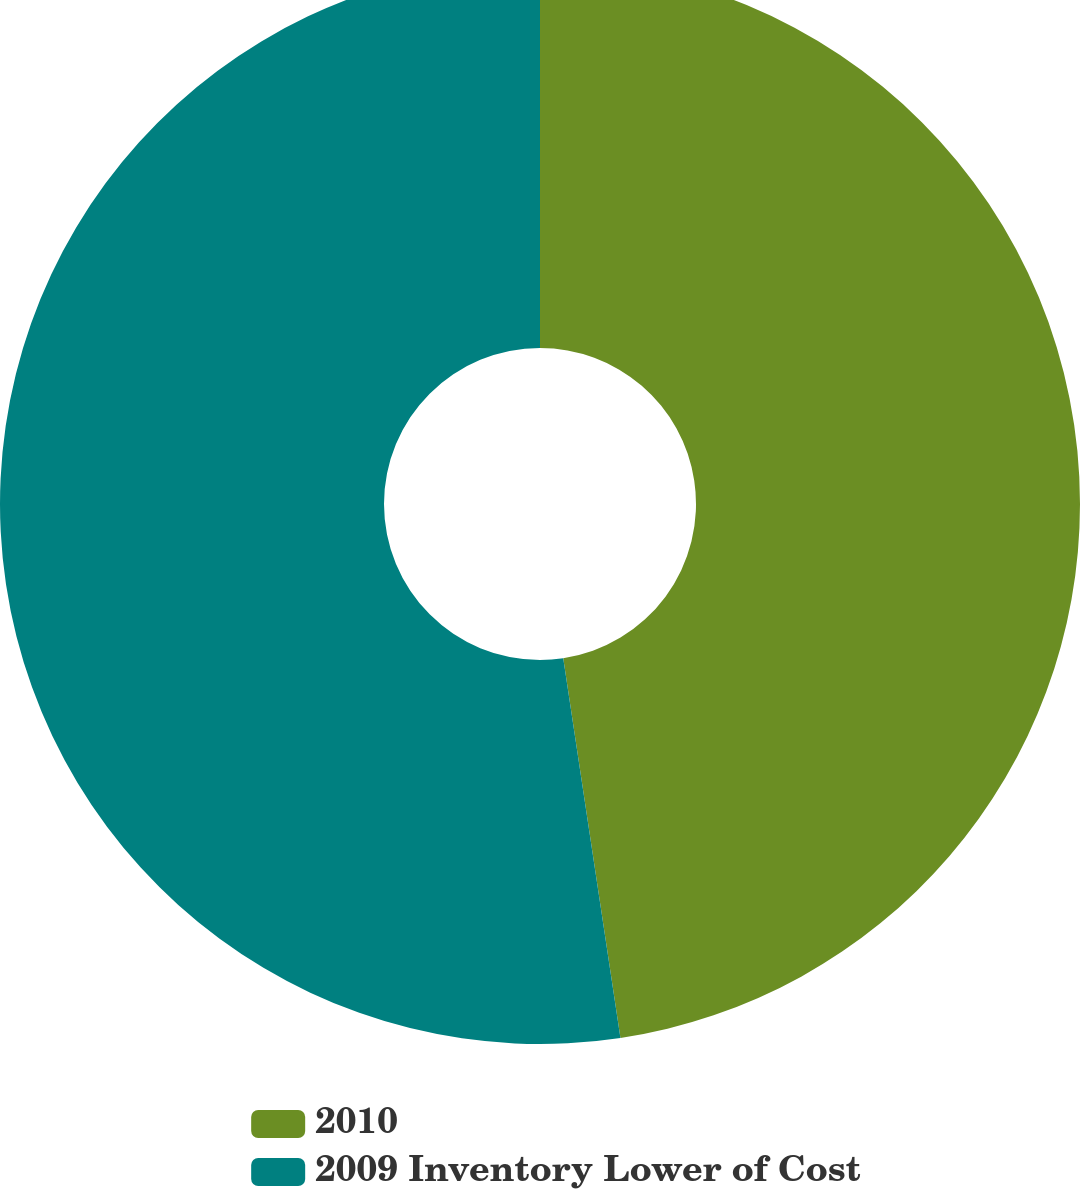Convert chart to OTSL. <chart><loc_0><loc_0><loc_500><loc_500><pie_chart><fcel>2010<fcel>2009 Inventory Lower of Cost<nl><fcel>47.62%<fcel>52.38%<nl></chart> 